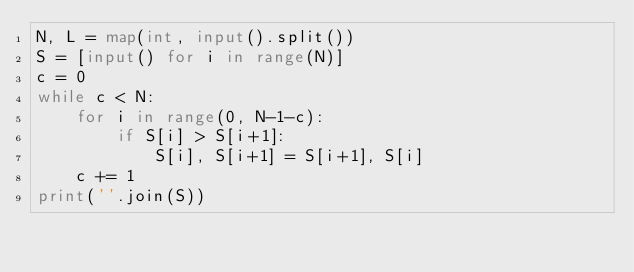<code> <loc_0><loc_0><loc_500><loc_500><_Python_>N, L = map(int, input().split())
S = [input() for i in range(N)]
c = 0
while c < N:
    for i in range(0, N-1-c):
        if S[i] > S[i+1]:
            S[i], S[i+1] = S[i+1], S[i]
    c += 1
print(''.join(S))
</code> 